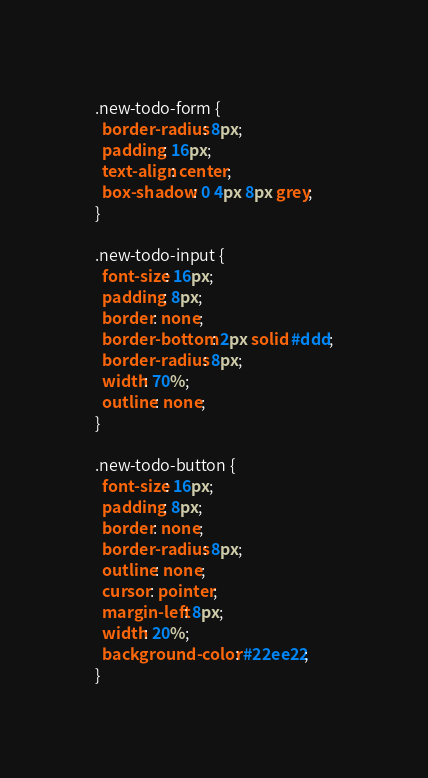Convert code to text. <code><loc_0><loc_0><loc_500><loc_500><_CSS_>.new-todo-form {
  border-radius: 8px;
  padding: 16px;
  text-align: center;
  box-shadow: 0 4px 8px grey;
}

.new-todo-input {
  font-size: 16px;
  padding: 8px;
  border: none;
  border-bottom: 2px solid #ddd;
  border-radius: 8px;
  width: 70%;
  outline: none;
}

.new-todo-button {
  font-size: 16px;
  padding: 8px;
  border: none;
  border-radius: 8px;
  outline: none;
  cursor: pointer;
  margin-left: 8px;
  width: 20%;
  background-color: #22ee22;
}</code> 